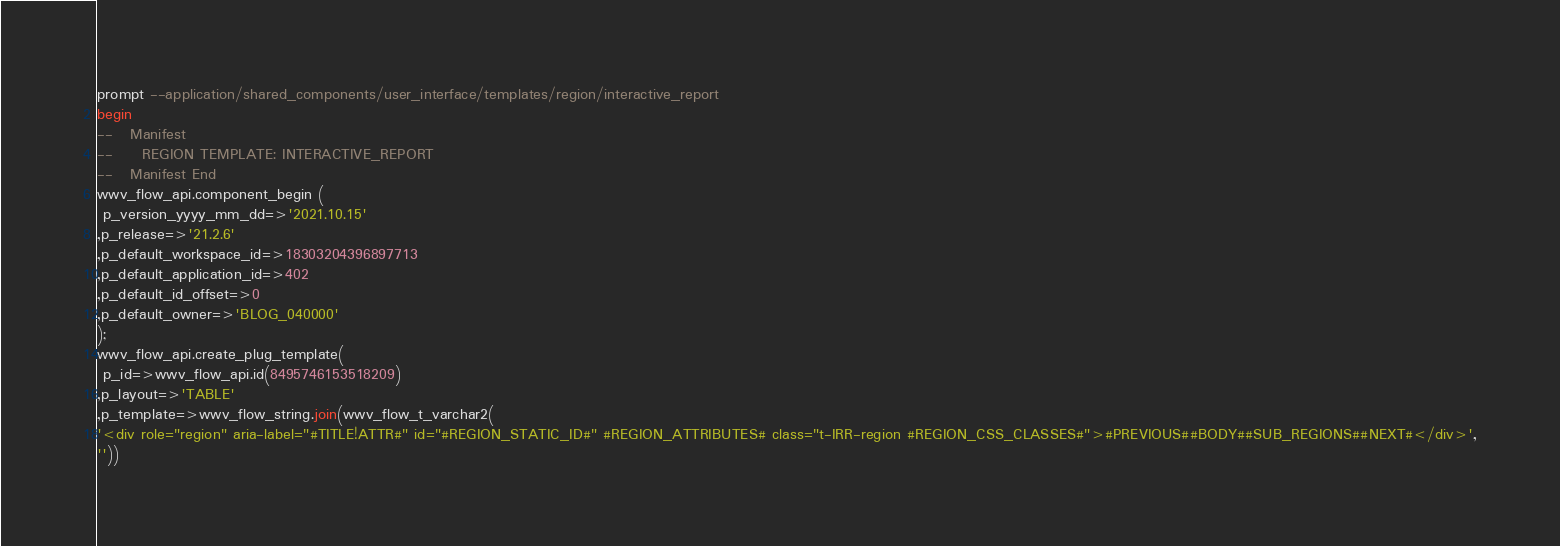<code> <loc_0><loc_0><loc_500><loc_500><_SQL_>prompt --application/shared_components/user_interface/templates/region/interactive_report
begin
--   Manifest
--     REGION TEMPLATE: INTERACTIVE_REPORT
--   Manifest End
wwv_flow_api.component_begin (
 p_version_yyyy_mm_dd=>'2021.10.15'
,p_release=>'21.2.6'
,p_default_workspace_id=>18303204396897713
,p_default_application_id=>402
,p_default_id_offset=>0
,p_default_owner=>'BLOG_040000'
);
wwv_flow_api.create_plug_template(
 p_id=>wwv_flow_api.id(8495746153518209)
,p_layout=>'TABLE'
,p_template=>wwv_flow_string.join(wwv_flow_t_varchar2(
'<div role="region" aria-label="#TITLE!ATTR#" id="#REGION_STATIC_ID#" #REGION_ATTRIBUTES# class="t-IRR-region #REGION_CSS_CLASSES#">#PREVIOUS##BODY##SUB_REGIONS##NEXT#</div>',
''))</code> 